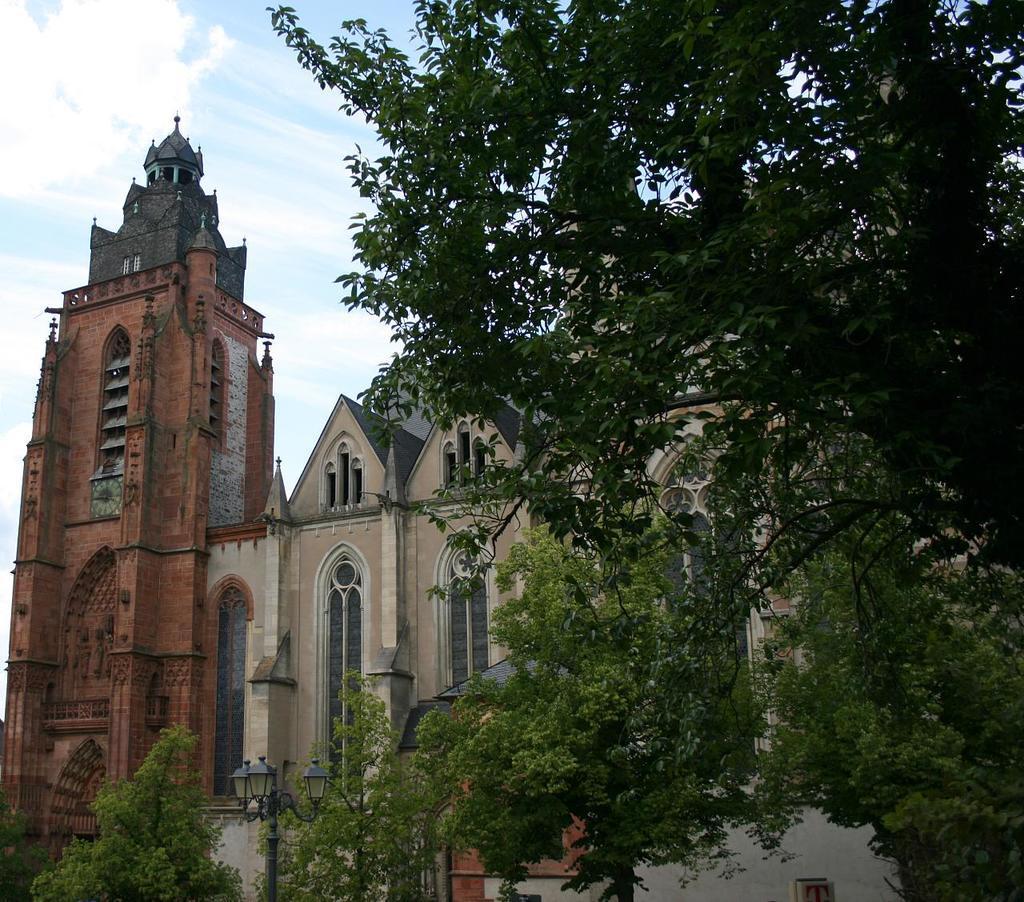Describe this image in one or two sentences. This is a building with the windows. These are the trees with branches and leaves. At the bottom of the image, I can see a light pole. This is the sky. 